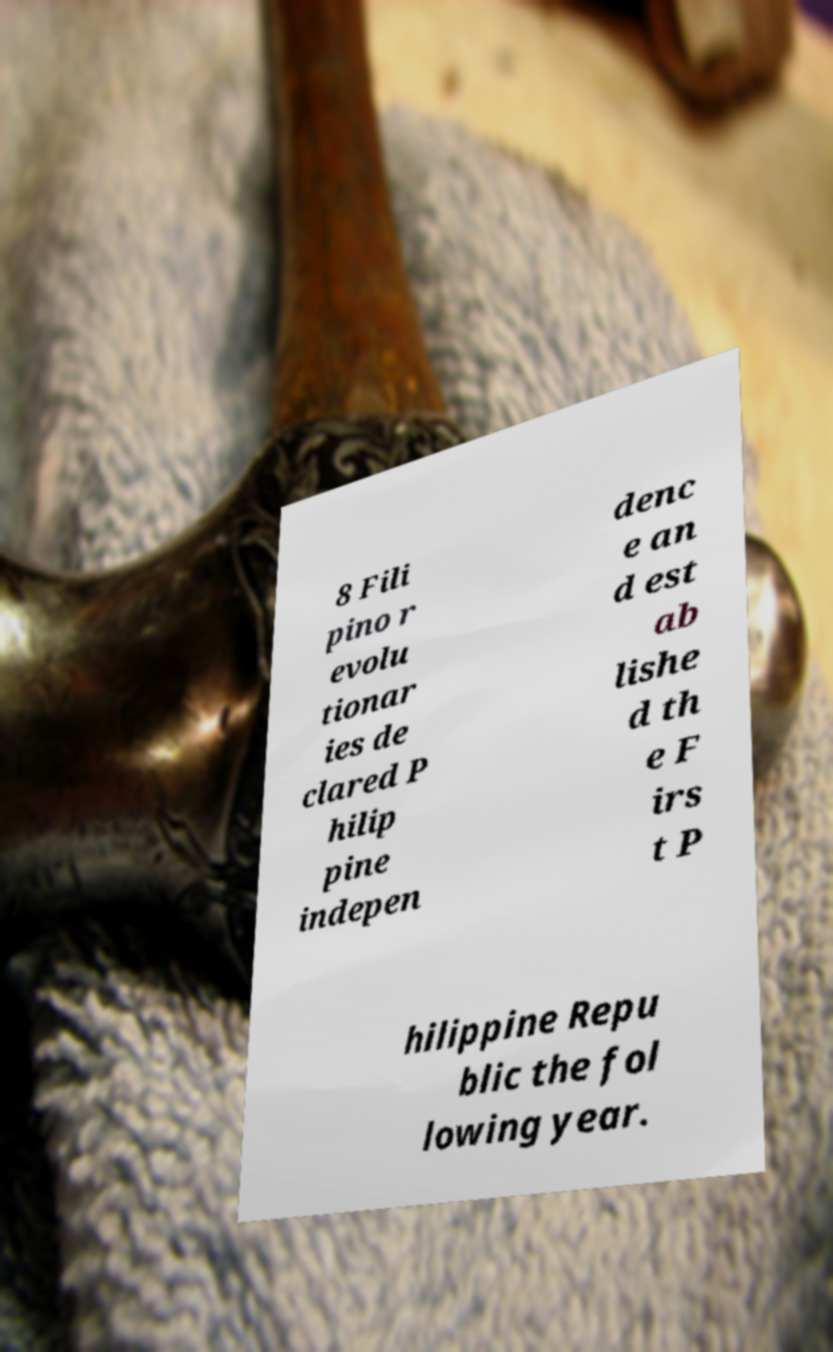There's text embedded in this image that I need extracted. Can you transcribe it verbatim? 8 Fili pino r evolu tionar ies de clared P hilip pine indepen denc e an d est ab lishe d th e F irs t P hilippine Repu blic the fol lowing year. 